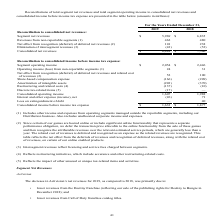According to Activision Blizzard's financial document, What does intersegment revenues reflect? licensing and service fees charged between segments.. The document states: "(3) Intersegment revenues reflect licensing and service fees charged between segments...." Also, What is the segment operating income in 2019? According to the financial document, $2,054 (in millions). The relevant text states: "re income tax expense: Segment operating income $ 2,054 $ 2,446..." Also, What is the segment net revenues in 2018? According to the financial document, $6,835 (in millions). The relevant text states: "ated net revenues: Segment net revenues $ 5,969 $ 6,835..." Also, can you calculate: What is the percentage change in segment net revenues between 2018 and 2019? To answer this question, I need to perform calculations using the financial data. The calculation is: ($5,969-$6,835)/$6,835, which equals -12.67 (percentage). This is based on the information: "ated net revenues: Segment net revenues $ 5,969 $ 6,835 consolidated net revenues: Segment net revenues $ 5,969 $ 6,835..." The key data points involved are: 5,969, 6,835. Also, can you calculate: What is the percentage change in segment operating income between 2018 and 2019? To answer this question, I need to perform calculations using the financial data. The calculation is: ($2,054-$2,446)/$2,446, which equals -16.03 (percentage). This is based on the information: "e tax expense: Segment operating income $ 2,054 $ 2,446 re income tax expense: Segment operating income $ 2,054 $ 2,446..." The key data points involved are: 2,054, 2,446. Also, can you calculate: What is the change in revenues from non-reportable segments between 2018 and 2019? Based on the calculation: (462-480), the result is -18 (in millions). This is based on the information: "Revenues from non-reportable segments (1) 462 480 Revenues from non-reportable segments (1) 462 480..." The key data points involved are: 462, 480. 